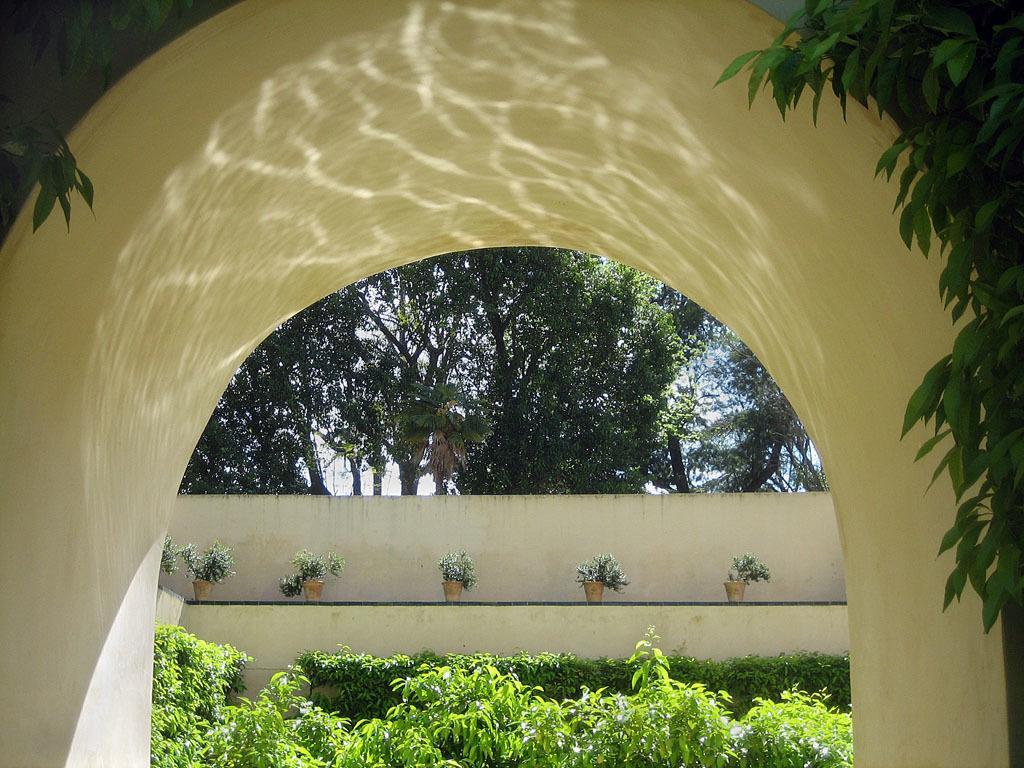Can you describe this image briefly? In this picture i can see the arch. In the back i can see the plant and pots which are kept on the wall. At the bottom i can see the plants. In the background i can see the sky. 